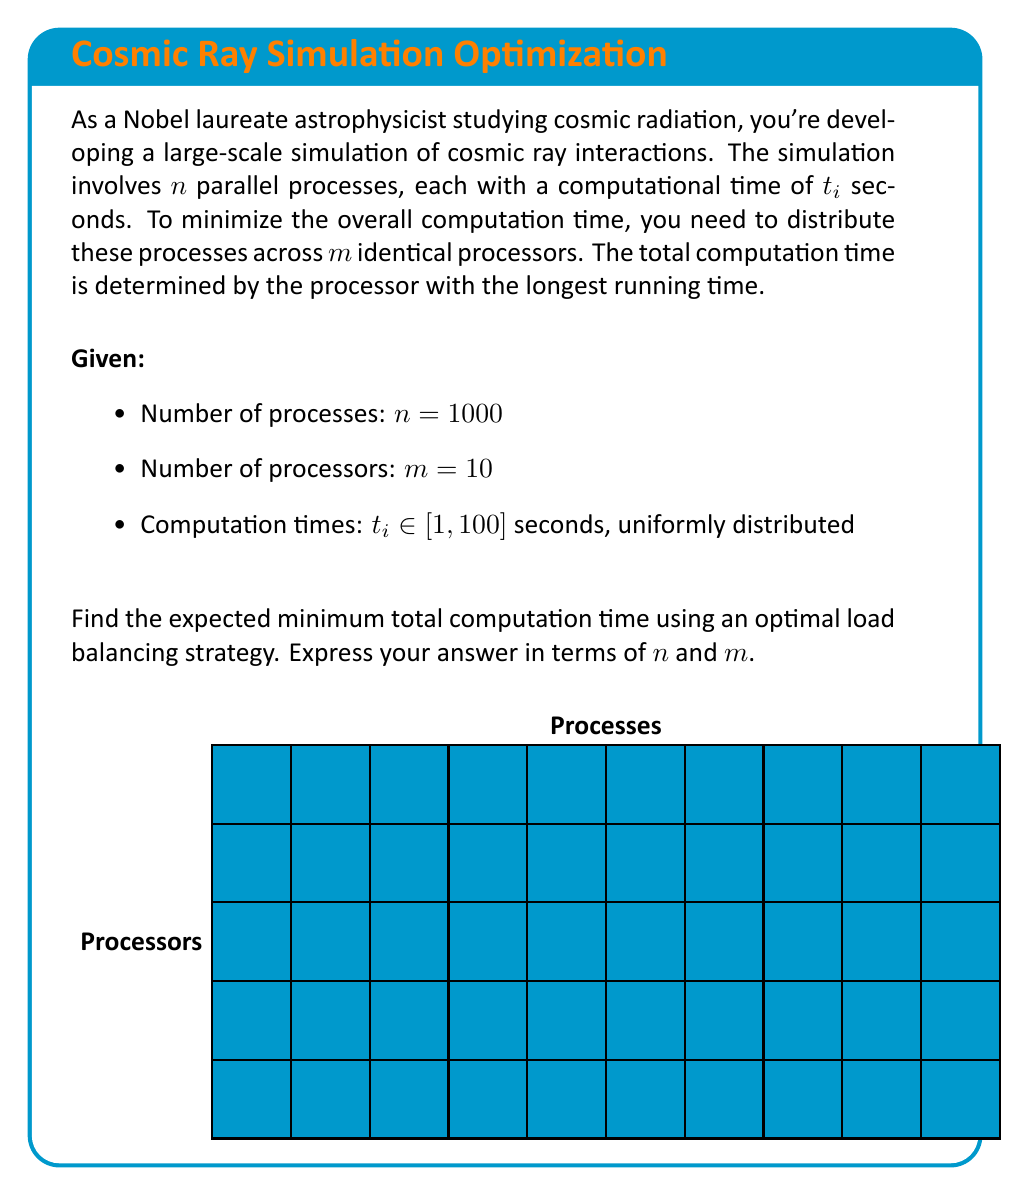Give your solution to this math problem. To solve this problem, we'll use the concept of load balancing and the properties of uniform distribution:

1) In an optimal load balancing strategy, we aim to distribute the processes as evenly as possible across the processors.

2) With $n$ processes and $m$ processors, each processor will handle approximately $\frac{n}{m}$ processes.

3) The computation times are uniformly distributed between 1 and 100 seconds. The expected value of a uniform distribution is the average of its minimum and maximum values:

   $E[t_i] = \frac{1 + 100}{2} = 50.5$ seconds

4) For large $n$, we can approximate the total computation time on each processor as the sum of $\frac{n}{m}$ independent random variables, each with an expected value of 50.5 seconds.

5) By the Central Limit Theorem, the sum of these random variables will approach a normal distribution with:
   
   Mean: $\mu = \frac{n}{m} \cdot 50.5$
   
   Variance: $\sigma^2 = \frac{n}{m} \cdot \frac{(100-1)^2}{12}$ (variance of uniform distribution)

6) The expected maximum of $m$ independent normal distributions can be approximated using the formula:

   $E[\max(X_1, ..., X_m)] \approx \mu + \sigma \cdot \sqrt{2 \ln m}$

7) Substituting our values:

   $E[\text{total time}] \approx \frac{50.5n}{m} + \sqrt{\frac{n(100-1)^2}{12m}} \cdot \sqrt{2 \ln m}$

8) Simplifying:

   $E[\text{total time}] \approx \frac{50.5n}{m} + 28.72 \sqrt{\frac{n}{m}} \cdot \sqrt{\ln m}$

This formula gives the expected minimum total computation time for any $n$ and $m$.
Answer: $\frac{50.5n}{m} + 28.72 \sqrt{\frac{n}{m}} \cdot \sqrt{\ln m}$ seconds 